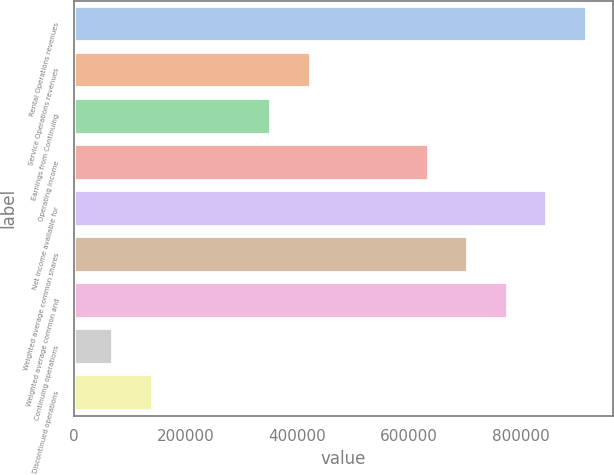Convert chart. <chart><loc_0><loc_0><loc_500><loc_500><bar_chart><fcel>Rental Operations revenues<fcel>Service Operations revenues<fcel>Earnings from Continuing<fcel>Operating income<fcel>Net income available for<fcel>Weighted average common shares<fcel>Weighted average common and<fcel>Continuing operations<fcel>Discontinued operations<nl><fcel>918038<fcel>423710<fcel>353092<fcel>635565<fcel>847419<fcel>706183<fcel>776801<fcel>70618.9<fcel>141237<nl></chart> 